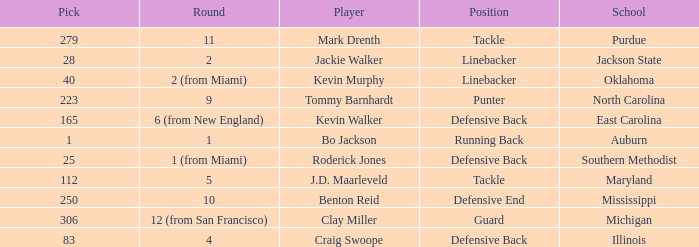What is the highest pick for a player from auburn? 1.0. 